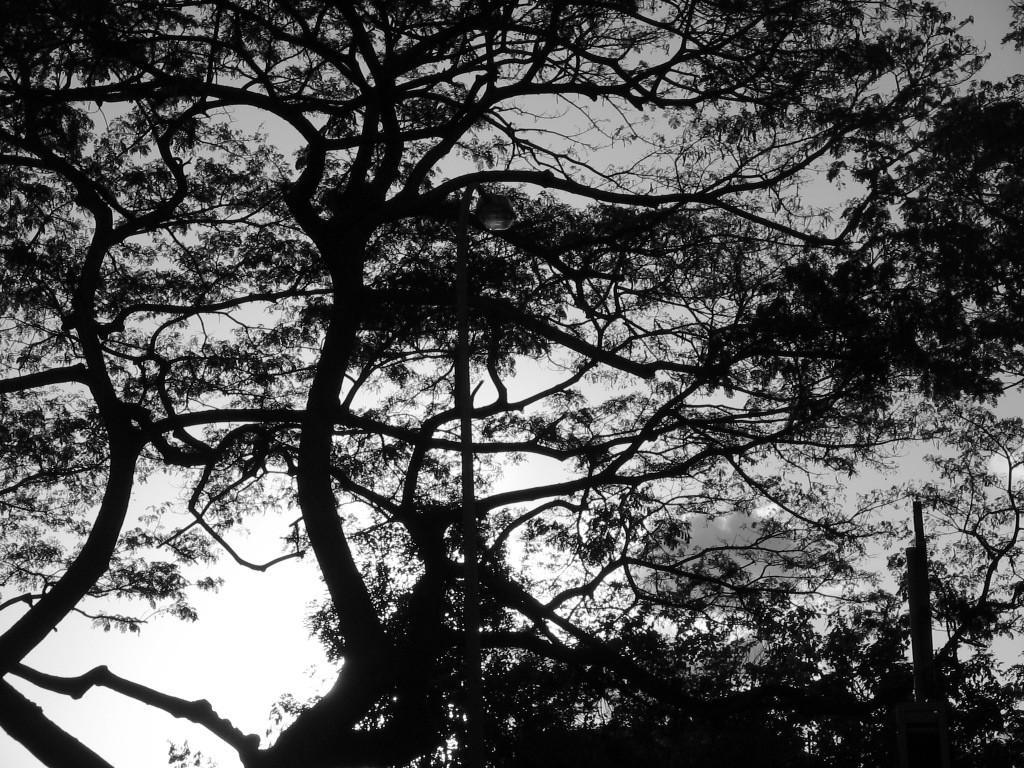In one or two sentences, can you explain what this image depicts? This image is a black and white image. This image is taken outdoors. In the background there is the sky with clouds. In the middle of the image there are a few trees with stems, branches and leaves. 